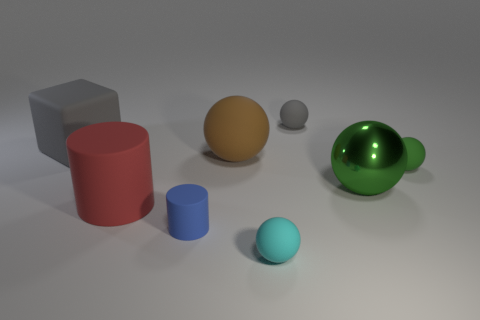Subtract all gray balls. How many balls are left? 4 Subtract all tiny gray spheres. How many spheres are left? 4 Subtract all purple spheres. Subtract all purple cubes. How many spheres are left? 5 Add 2 large gray metallic balls. How many objects exist? 10 Subtract all cylinders. How many objects are left? 6 Subtract all tiny gray cylinders. Subtract all rubber objects. How many objects are left? 1 Add 6 big matte cylinders. How many big matte cylinders are left? 7 Add 7 small cyan metal balls. How many small cyan metal balls exist? 7 Subtract 0 yellow cylinders. How many objects are left? 8 